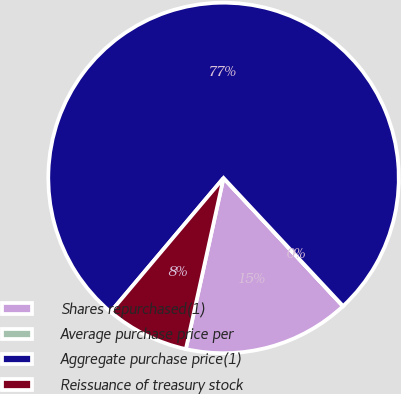Convert chart to OTSL. <chart><loc_0><loc_0><loc_500><loc_500><pie_chart><fcel>Shares repurchased(1)<fcel>Average purchase price per<fcel>Aggregate purchase price(1)<fcel>Reissuance of treasury stock<nl><fcel>15.39%<fcel>0.01%<fcel>76.9%<fcel>7.7%<nl></chart> 